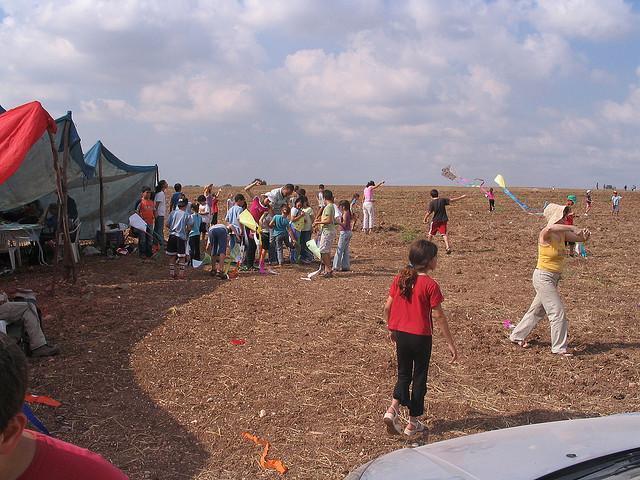How many people are there?
Give a very brief answer. 4. 